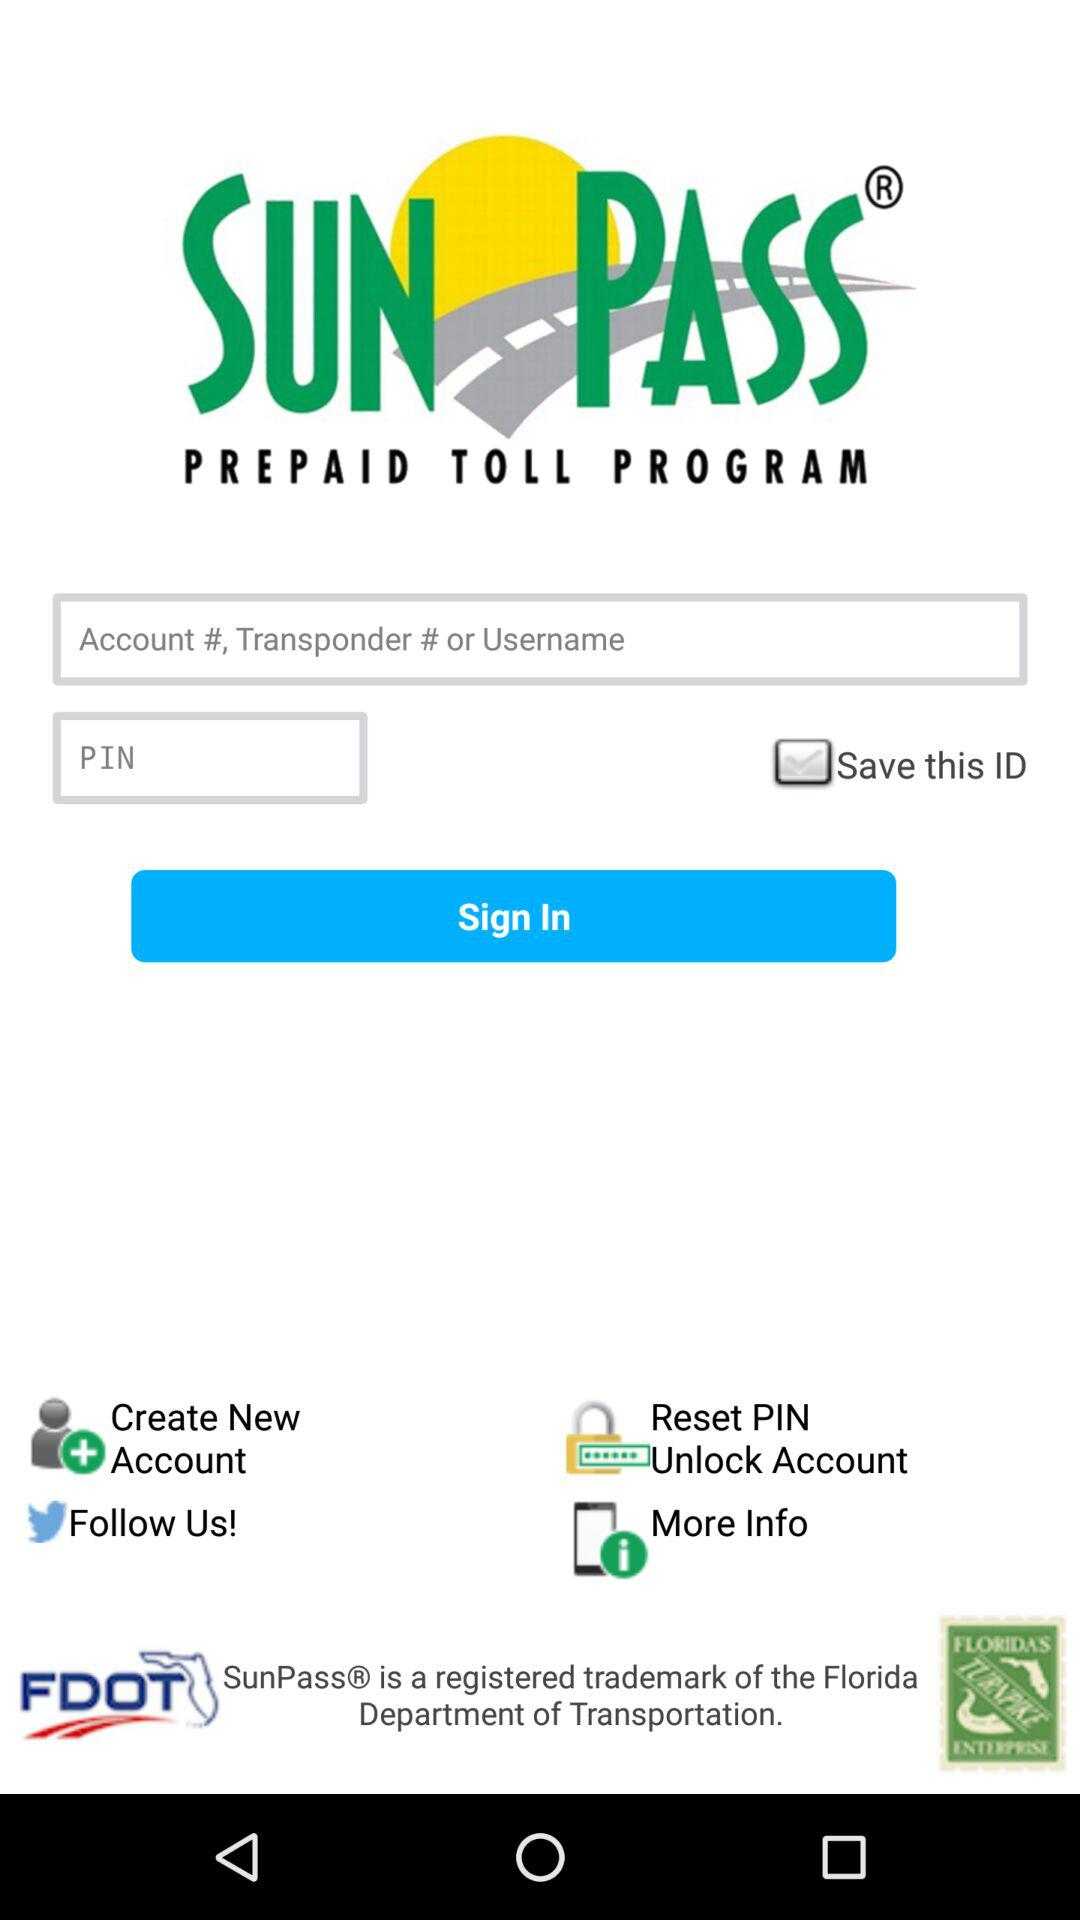What is the application name? The application name is "SUN PASS". 